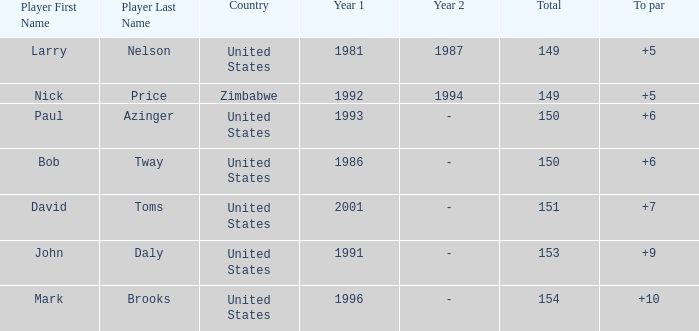Which player won in 1993? Paul Azinger. Parse the table in full. {'header': ['Player First Name', 'Player Last Name', 'Country', 'Year 1', 'Year 2', 'Total', 'To par'], 'rows': [['Larry', 'Nelson', 'United States', '1981', '1987', '149', '+5'], ['Nick', 'Price', 'Zimbabwe', '1992', '1994', '149', '+5'], ['Paul', 'Azinger', 'United States', '1993', '-', '150', '+6'], ['Bob', 'Tway', 'United States', '1986', '-', '150', '+6'], ['David', 'Toms', 'United States', '2001', '-', '151', '+7'], ['John', 'Daly', 'United States', '1991', '-', '153', '+9'], ['Mark', 'Brooks', 'United States', '1996', '-', '154', '+10']]} 